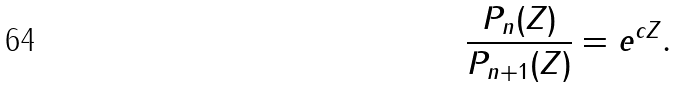Convert formula to latex. <formula><loc_0><loc_0><loc_500><loc_500>\frac { P _ { n } ( Z ) } { P _ { n + 1 } ( Z ) } = e ^ { c Z } .</formula> 